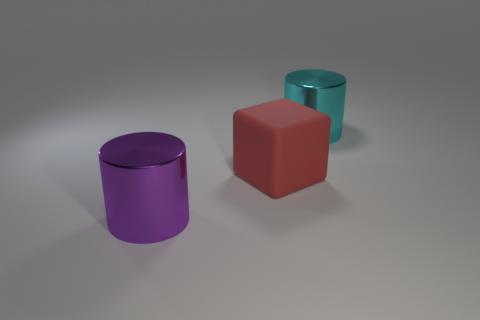What is the size of the other thing that is the same shape as the large purple metal object?
Keep it short and to the point. Large. Is the number of metal cylinders behind the cyan shiny object the same as the number of big cyan cylinders that are in front of the large rubber block?
Offer a terse response. Yes. There is a metal cylinder that is in front of the large cube; what is its size?
Make the answer very short. Large. Is there anything else that is the same shape as the big red object?
Keep it short and to the point. No. Are there an equal number of large cyan cylinders that are behind the big cyan shiny cylinder and blue things?
Provide a succinct answer. Yes. Are there any big cyan metallic cylinders behind the big red matte thing?
Your answer should be very brief. Yes. Is the shape of the cyan object the same as the large red object to the left of the big cyan thing?
Provide a short and direct response. No. What is the color of the thing that is made of the same material as the large cyan cylinder?
Make the answer very short. Purple. What color is the matte cube?
Offer a terse response. Red. Is the material of the large red thing the same as the cylinder that is left of the large cyan metallic cylinder?
Ensure brevity in your answer.  No. 